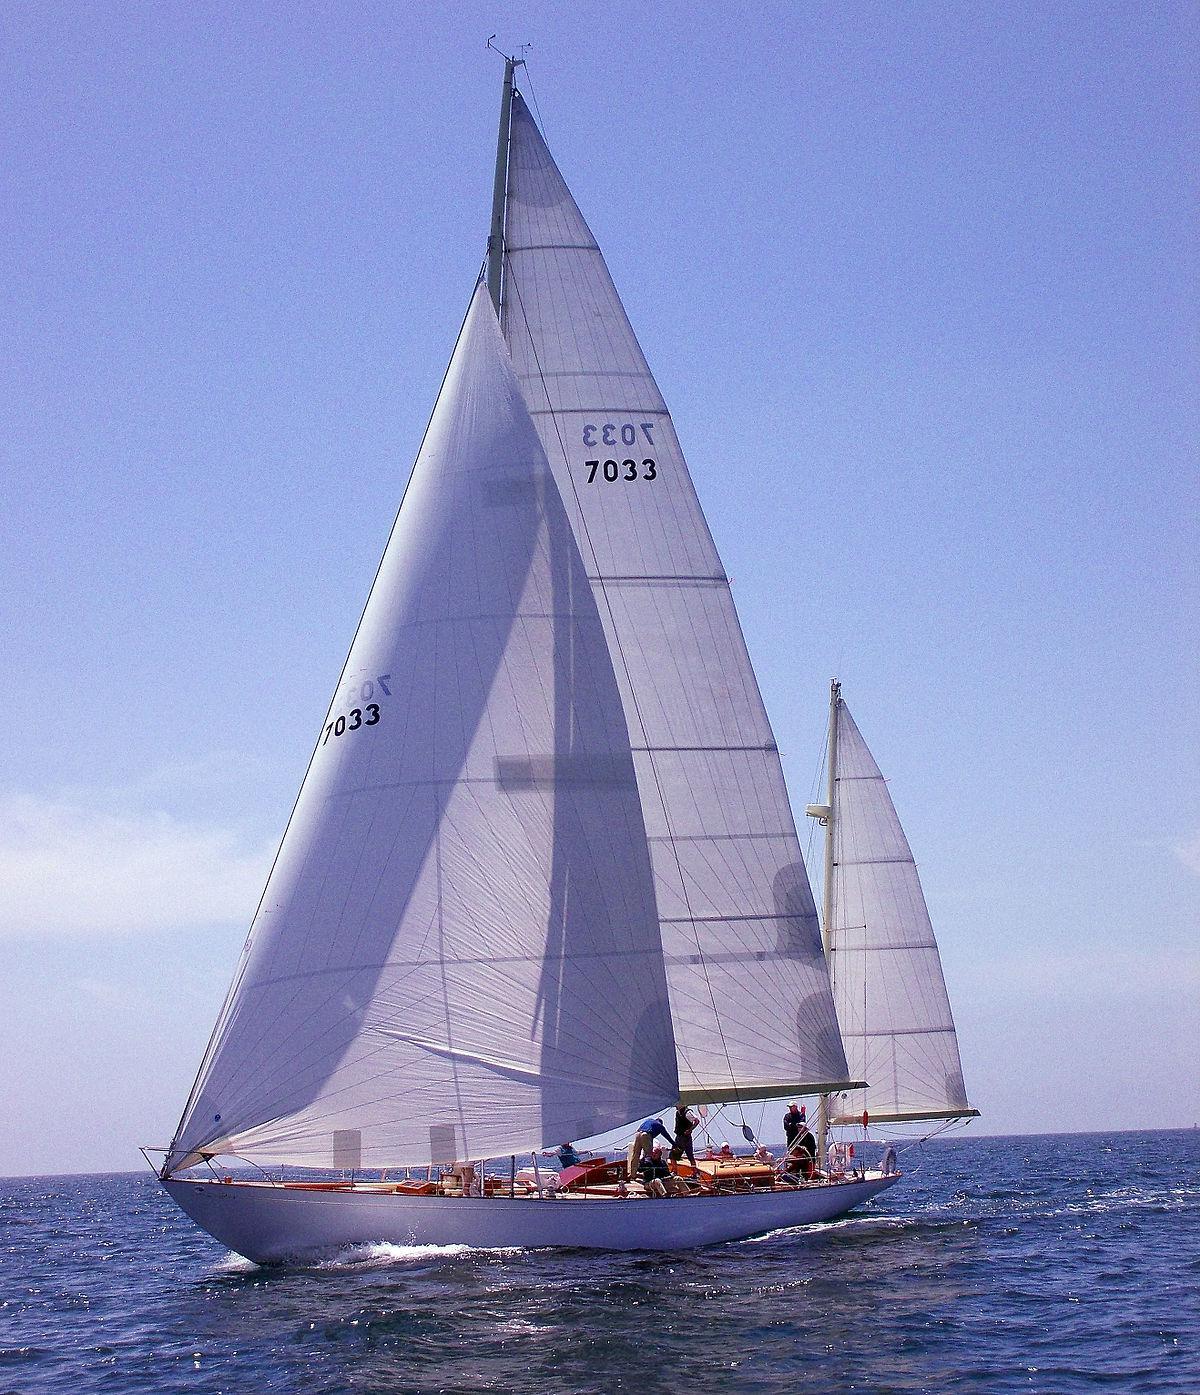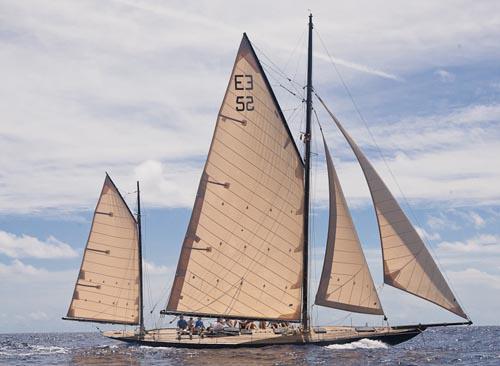The first image is the image on the left, the second image is the image on the right. Assess this claim about the two images: "There are more boats in the image on the right than the image on the left.". Correct or not? Answer yes or no. No. 